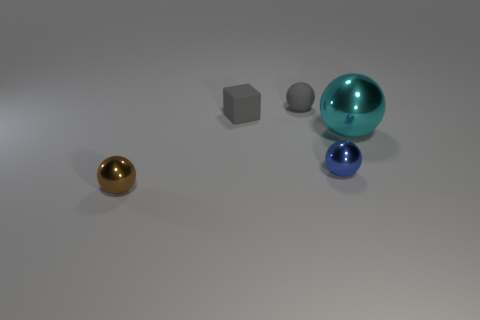Subtract all small brown spheres. How many spheres are left? 3 Add 4 cubes. How many objects exist? 9 Subtract 1 blocks. How many blocks are left? 0 Subtract all brown spheres. How many spheres are left? 3 Subtract all spheres. How many objects are left? 1 Subtract all large blue matte cubes. Subtract all small gray blocks. How many objects are left? 4 Add 1 small blue shiny balls. How many small blue shiny balls are left? 2 Add 2 small red matte cubes. How many small red matte cubes exist? 2 Subtract 0 blue blocks. How many objects are left? 5 Subtract all brown balls. Subtract all green cubes. How many balls are left? 3 